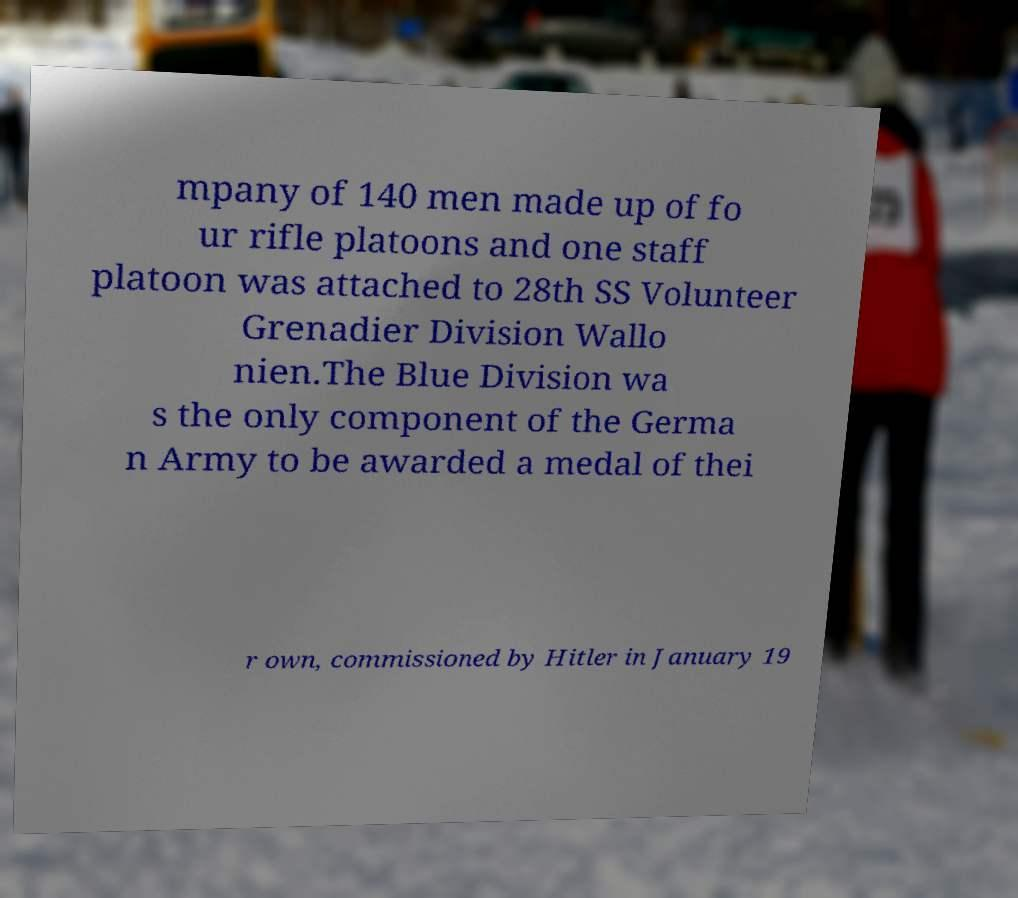Could you assist in decoding the text presented in this image and type it out clearly? mpany of 140 men made up of fo ur rifle platoons and one staff platoon was attached to 28th SS Volunteer Grenadier Division Wallo nien.The Blue Division wa s the only component of the Germa n Army to be awarded a medal of thei r own, commissioned by Hitler in January 19 